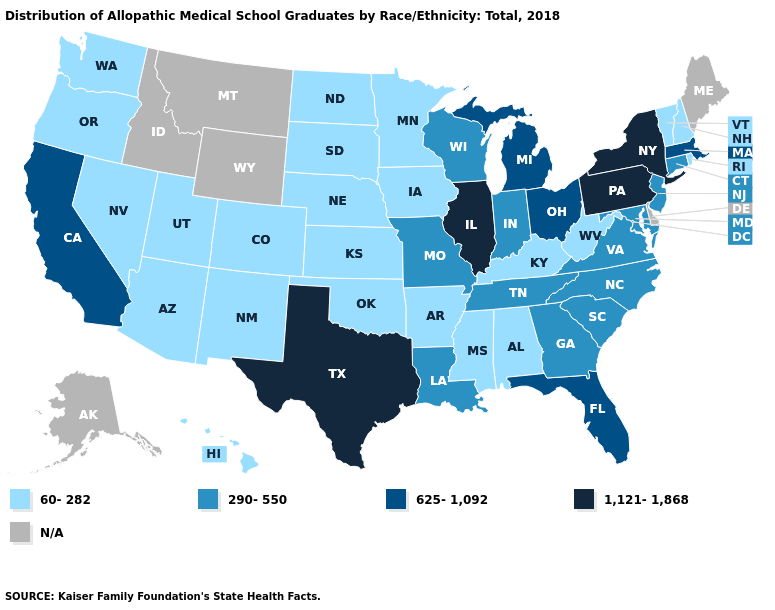What is the value of Florida?
Be succinct. 625-1,092. Name the states that have a value in the range 1,121-1,868?
Write a very short answer. Illinois, New York, Pennsylvania, Texas. What is the value of South Carolina?
Concise answer only. 290-550. Among the states that border Georgia , does Alabama have the lowest value?
Be succinct. Yes. What is the value of Missouri?
Quick response, please. 290-550. What is the highest value in the USA?
Be succinct. 1,121-1,868. Does Illinois have the highest value in the USA?
Answer briefly. Yes. What is the value of Florida?
Be succinct. 625-1,092. Name the states that have a value in the range 290-550?
Be succinct. Connecticut, Georgia, Indiana, Louisiana, Maryland, Missouri, New Jersey, North Carolina, South Carolina, Tennessee, Virginia, Wisconsin. Name the states that have a value in the range 60-282?
Quick response, please. Alabama, Arizona, Arkansas, Colorado, Hawaii, Iowa, Kansas, Kentucky, Minnesota, Mississippi, Nebraska, Nevada, New Hampshire, New Mexico, North Dakota, Oklahoma, Oregon, Rhode Island, South Dakota, Utah, Vermont, Washington, West Virginia. What is the value of North Dakota?
Short answer required. 60-282. What is the value of Massachusetts?
Give a very brief answer. 625-1,092. Which states have the highest value in the USA?
Give a very brief answer. Illinois, New York, Pennsylvania, Texas. 